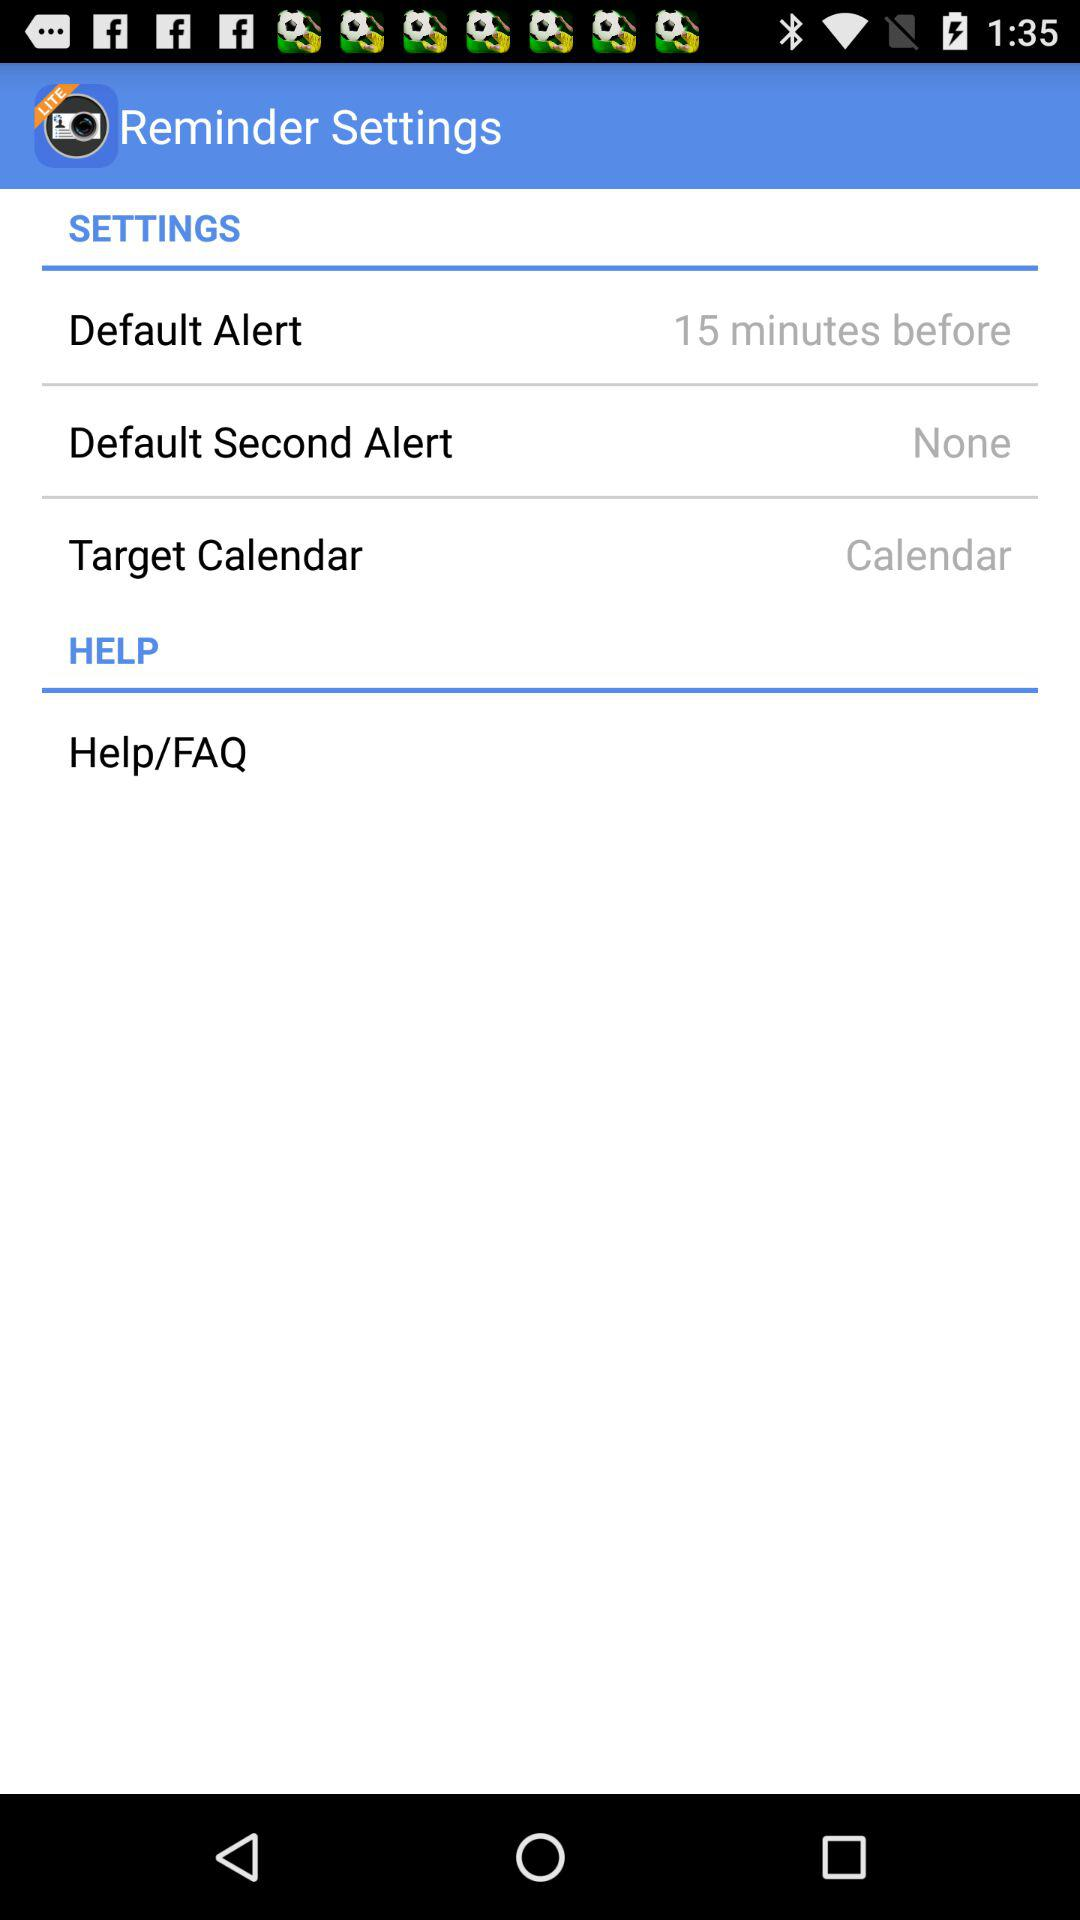What is the setting for default alert? The setting for default alert is "15 minutes before". 